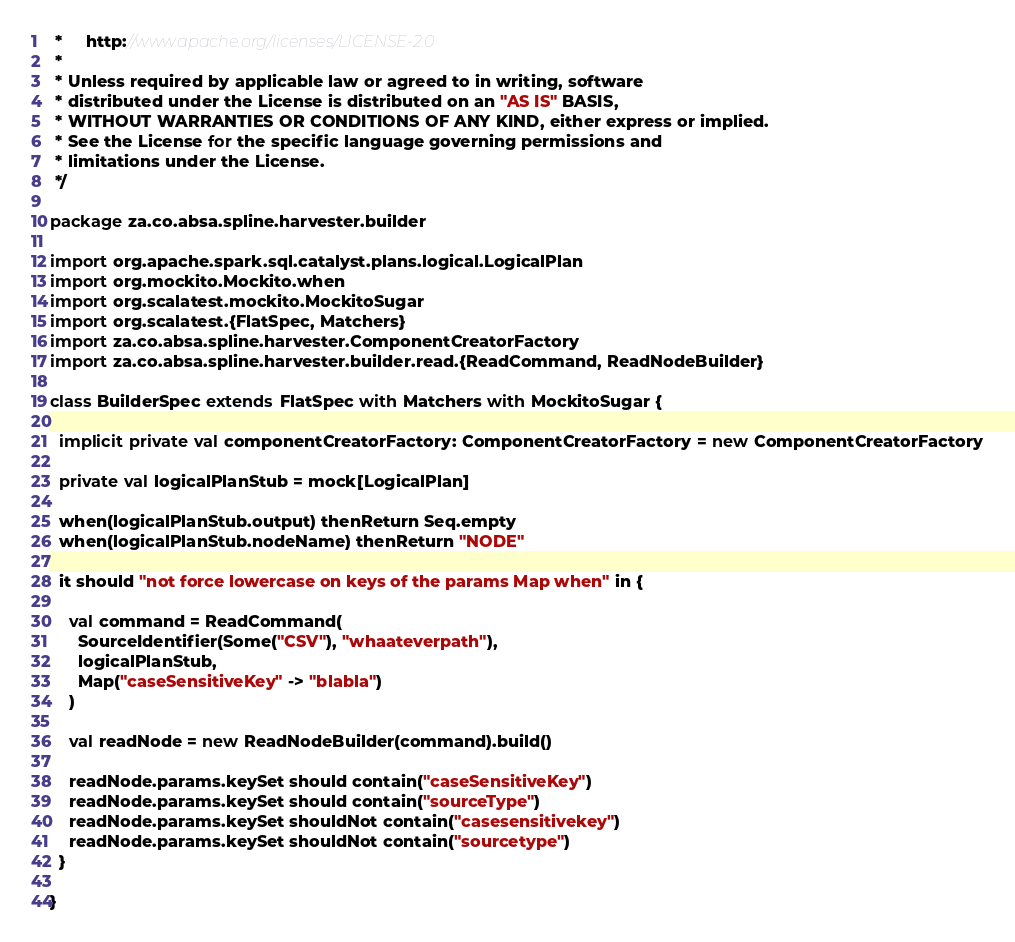<code> <loc_0><loc_0><loc_500><loc_500><_Scala_> *     http://www.apache.org/licenses/LICENSE-2.0
 *
 * Unless required by applicable law or agreed to in writing, software
 * distributed under the License is distributed on an "AS IS" BASIS,
 * WITHOUT WARRANTIES OR CONDITIONS OF ANY KIND, either express or implied.
 * See the License for the specific language governing permissions and
 * limitations under the License.
 */

package za.co.absa.spline.harvester.builder

import org.apache.spark.sql.catalyst.plans.logical.LogicalPlan
import org.mockito.Mockito.when
import org.scalatest.mockito.MockitoSugar
import org.scalatest.{FlatSpec, Matchers}
import za.co.absa.spline.harvester.ComponentCreatorFactory
import za.co.absa.spline.harvester.builder.read.{ReadCommand, ReadNodeBuilder}

class BuilderSpec extends FlatSpec with Matchers with MockitoSugar {

  implicit private val componentCreatorFactory: ComponentCreatorFactory = new ComponentCreatorFactory

  private val logicalPlanStub = mock[LogicalPlan]

  when(logicalPlanStub.output) thenReturn Seq.empty
  when(logicalPlanStub.nodeName) thenReturn "NODE"

  it should "not force lowercase on keys of the params Map when" in {

    val command = ReadCommand(
      SourceIdentifier(Some("CSV"), "whaateverpath"),
      logicalPlanStub,
      Map("caseSensitiveKey" -> "blabla")
    )

    val readNode = new ReadNodeBuilder(command).build()

    readNode.params.keySet should contain("caseSensitiveKey")
    readNode.params.keySet should contain("sourceType")
    readNode.params.keySet shouldNot contain("casesensitivekey")
    readNode.params.keySet shouldNot contain("sourcetype")
  }

}
</code> 